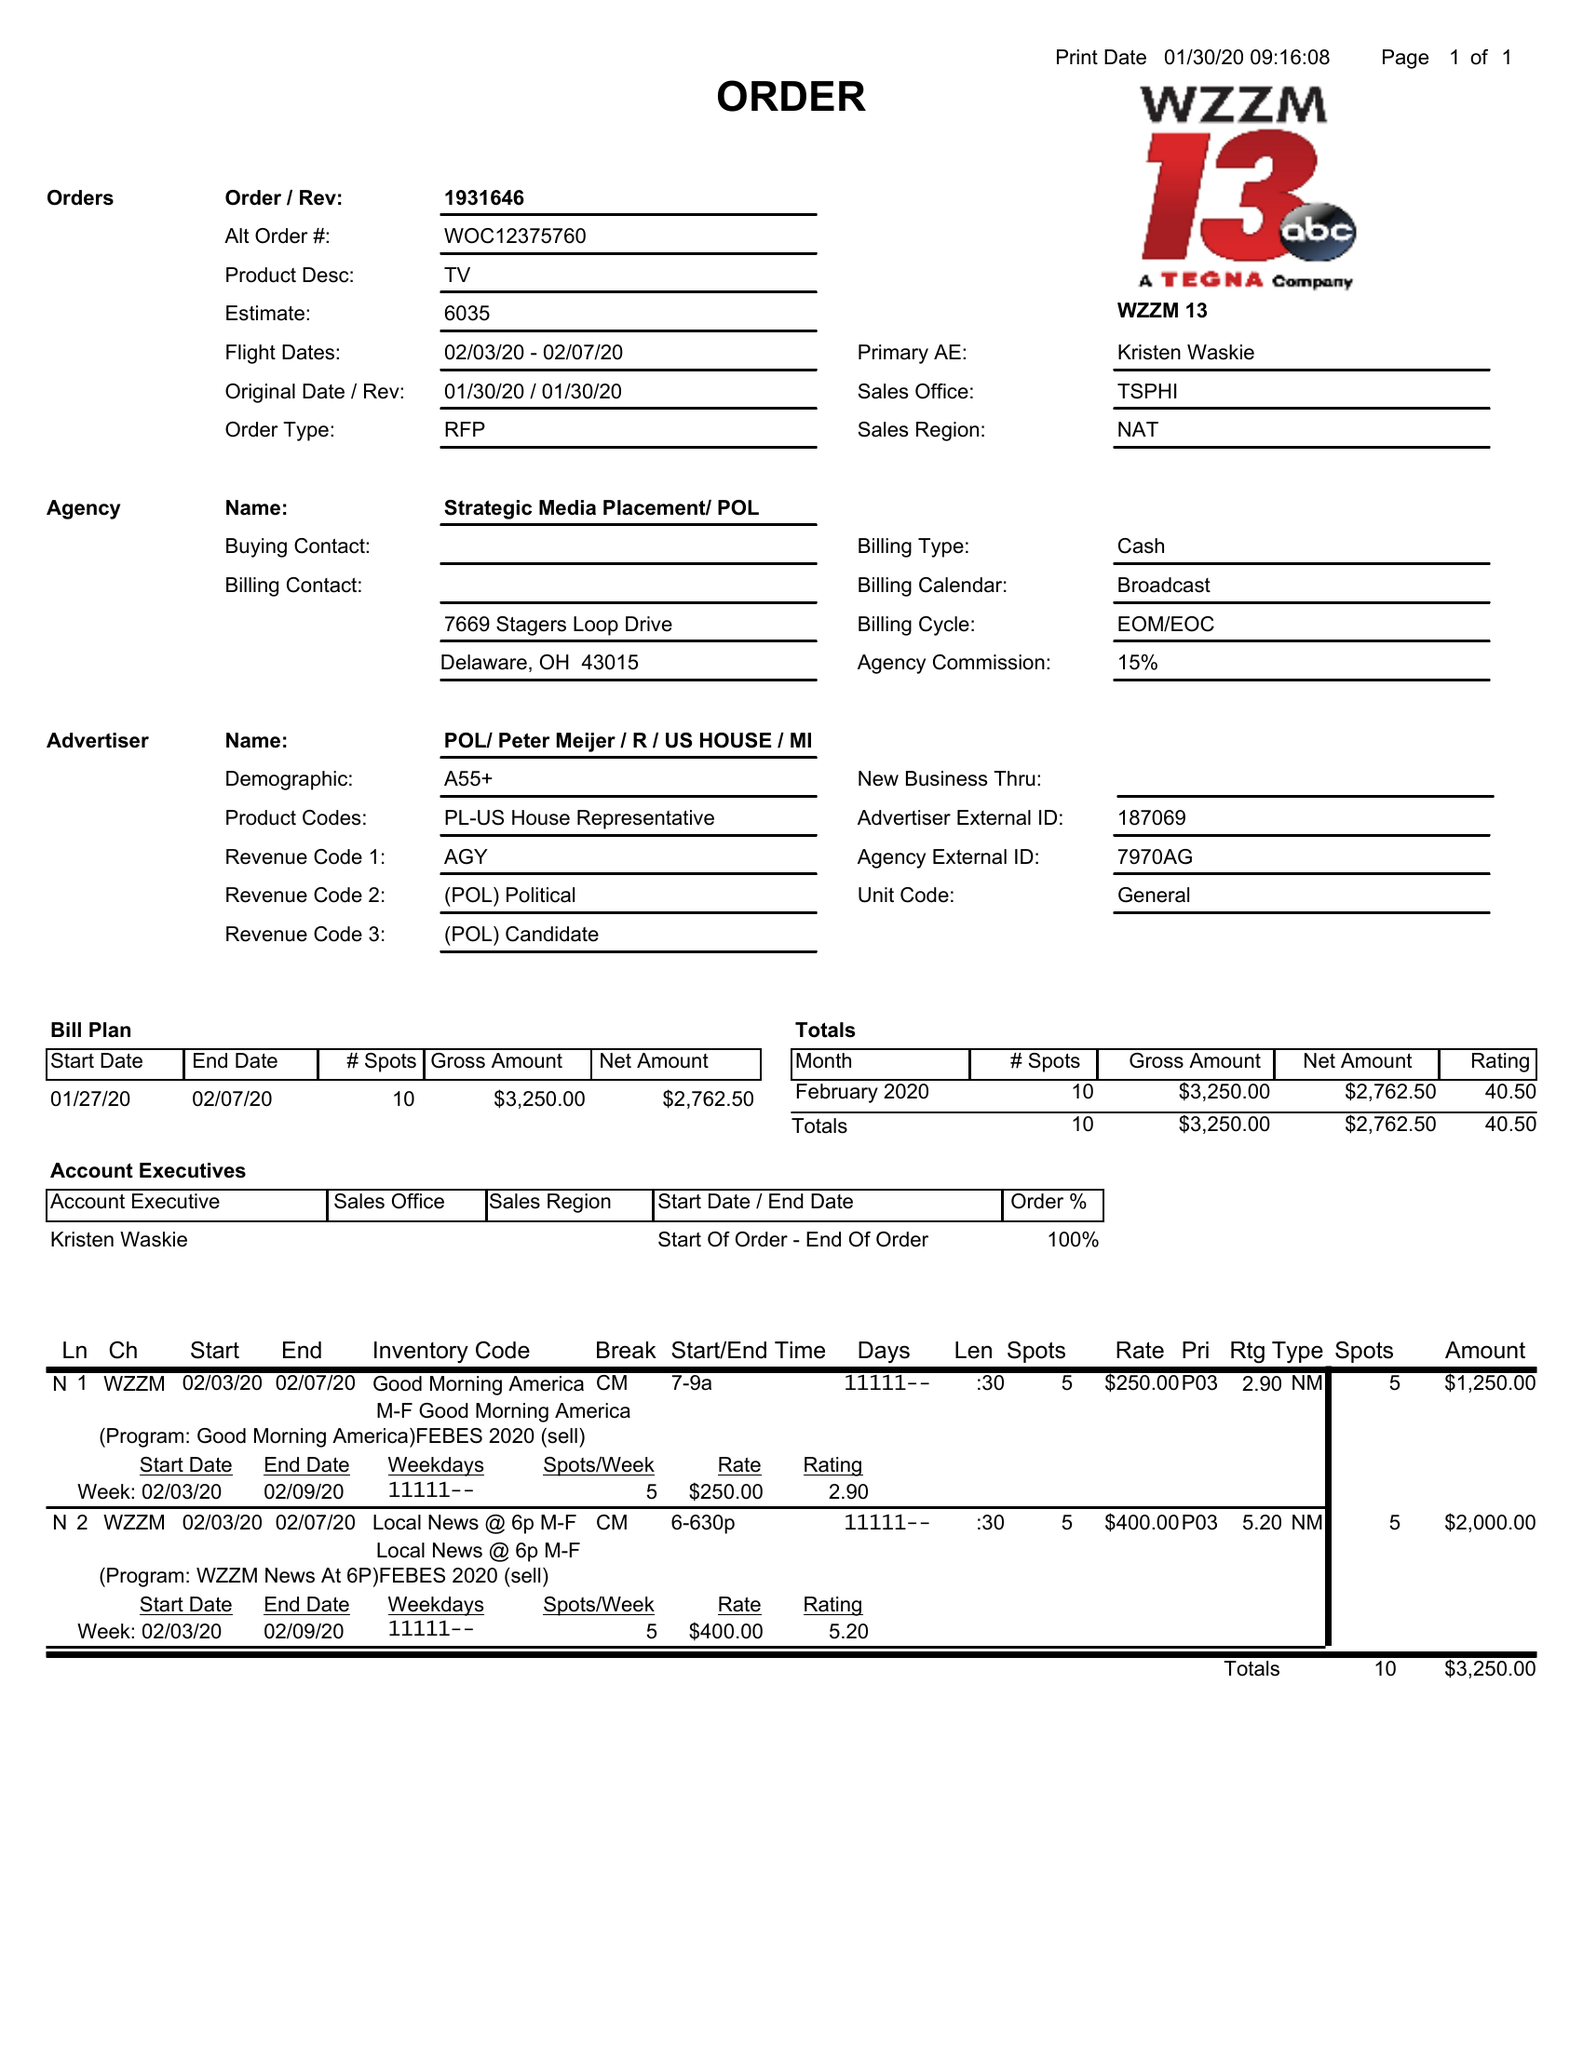What is the value for the gross_amount?
Answer the question using a single word or phrase. 3250.00 